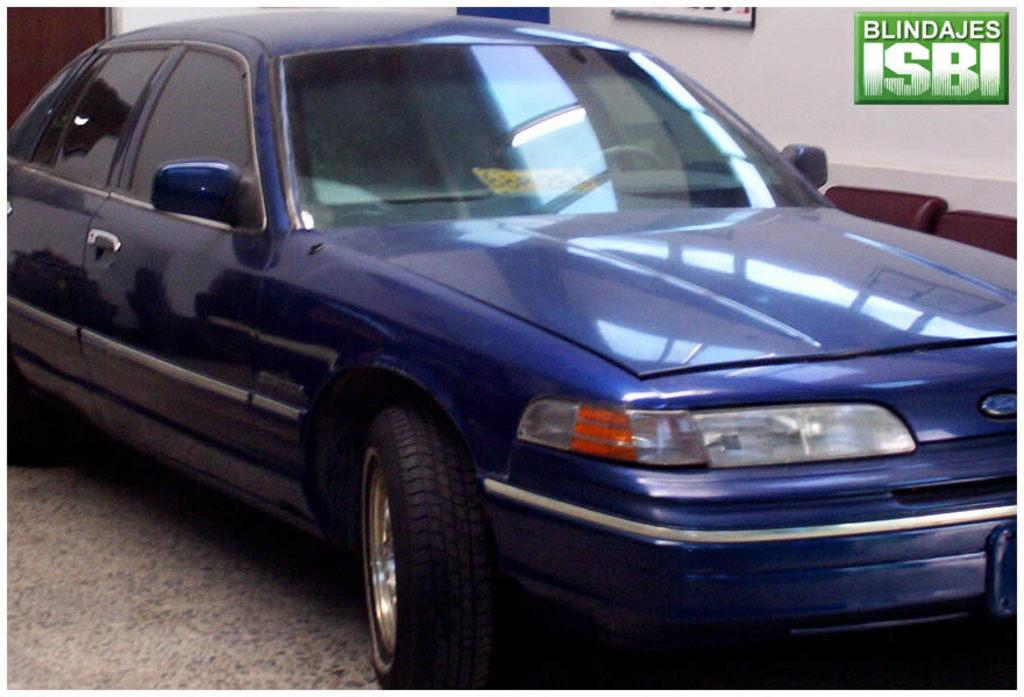What color is the car in the image? The car in the image is blue. What can be seen on the wall in the image? There are boards on a wall in the image. Can you see any wounds on the car in the image? There are no wounds visible on the car in the image. What type of wax might be used to create the boards on the wall in the image? The type of wax used to create the boards on the wall is not visible or mentioned in the image. 